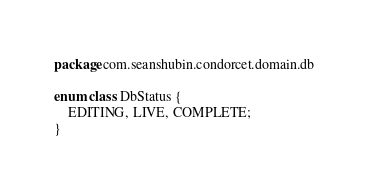<code> <loc_0><loc_0><loc_500><loc_500><_Kotlin_>package com.seanshubin.condorcet.domain.db

enum class DbStatus {
    EDITING, LIVE, COMPLETE;
}
</code> 